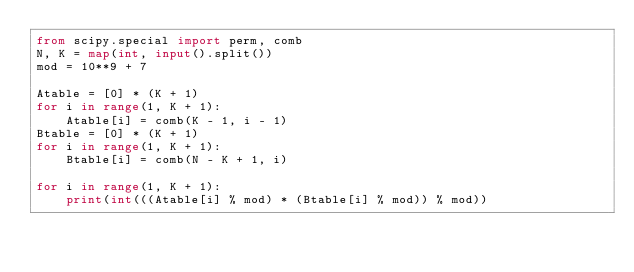<code> <loc_0><loc_0><loc_500><loc_500><_Python_>from scipy.special import perm, comb
N, K = map(int, input().split())
mod = 10**9 + 7

Atable = [0] * (K + 1)
for i in range(1, K + 1):
    Atable[i] = comb(K - 1, i - 1)
Btable = [0] * (K + 1)
for i in range(1, K + 1):
    Btable[i] = comb(N - K + 1, i)

for i in range(1, K + 1):
    print(int(((Atable[i] % mod) * (Btable[i] % mod)) % mod))</code> 